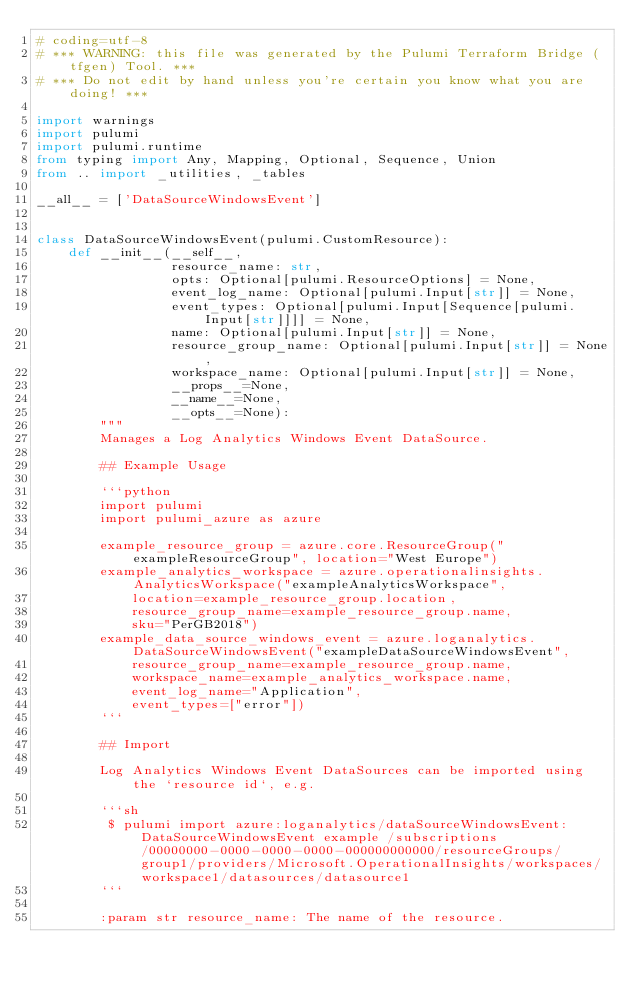<code> <loc_0><loc_0><loc_500><loc_500><_Python_># coding=utf-8
# *** WARNING: this file was generated by the Pulumi Terraform Bridge (tfgen) Tool. ***
# *** Do not edit by hand unless you're certain you know what you are doing! ***

import warnings
import pulumi
import pulumi.runtime
from typing import Any, Mapping, Optional, Sequence, Union
from .. import _utilities, _tables

__all__ = ['DataSourceWindowsEvent']


class DataSourceWindowsEvent(pulumi.CustomResource):
    def __init__(__self__,
                 resource_name: str,
                 opts: Optional[pulumi.ResourceOptions] = None,
                 event_log_name: Optional[pulumi.Input[str]] = None,
                 event_types: Optional[pulumi.Input[Sequence[pulumi.Input[str]]]] = None,
                 name: Optional[pulumi.Input[str]] = None,
                 resource_group_name: Optional[pulumi.Input[str]] = None,
                 workspace_name: Optional[pulumi.Input[str]] = None,
                 __props__=None,
                 __name__=None,
                 __opts__=None):
        """
        Manages a Log Analytics Windows Event DataSource.

        ## Example Usage

        ```python
        import pulumi
        import pulumi_azure as azure

        example_resource_group = azure.core.ResourceGroup("exampleResourceGroup", location="West Europe")
        example_analytics_workspace = azure.operationalinsights.AnalyticsWorkspace("exampleAnalyticsWorkspace",
            location=example_resource_group.location,
            resource_group_name=example_resource_group.name,
            sku="PerGB2018")
        example_data_source_windows_event = azure.loganalytics.DataSourceWindowsEvent("exampleDataSourceWindowsEvent",
            resource_group_name=example_resource_group.name,
            workspace_name=example_analytics_workspace.name,
            event_log_name="Application",
            event_types=["error"])
        ```

        ## Import

        Log Analytics Windows Event DataSources can be imported using the `resource id`, e.g.

        ```sh
         $ pulumi import azure:loganalytics/dataSourceWindowsEvent:DataSourceWindowsEvent example /subscriptions/00000000-0000-0000-0000-000000000000/resourceGroups/group1/providers/Microsoft.OperationalInsights/workspaces/workspace1/datasources/datasource1
        ```

        :param str resource_name: The name of the resource.</code> 